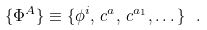Convert formula to latex. <formula><loc_0><loc_0><loc_500><loc_500>\{ \Phi ^ { A } \} \equiv \{ \phi ^ { i } , \, c ^ { a } , \, c ^ { a _ { 1 } } , \dots \} \ .</formula> 